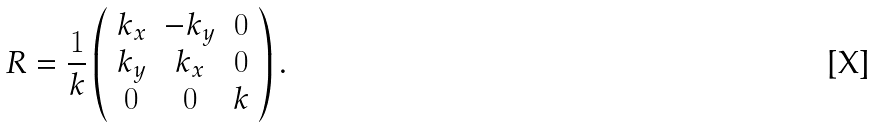Convert formula to latex. <formula><loc_0><loc_0><loc_500><loc_500>R = \frac { 1 } { k } \left ( \begin{array} { c c c } k _ { x } & - k _ { y } & 0 \\ k _ { y } & k _ { x } & 0 \\ 0 & 0 & k \end{array} \right ) .</formula> 